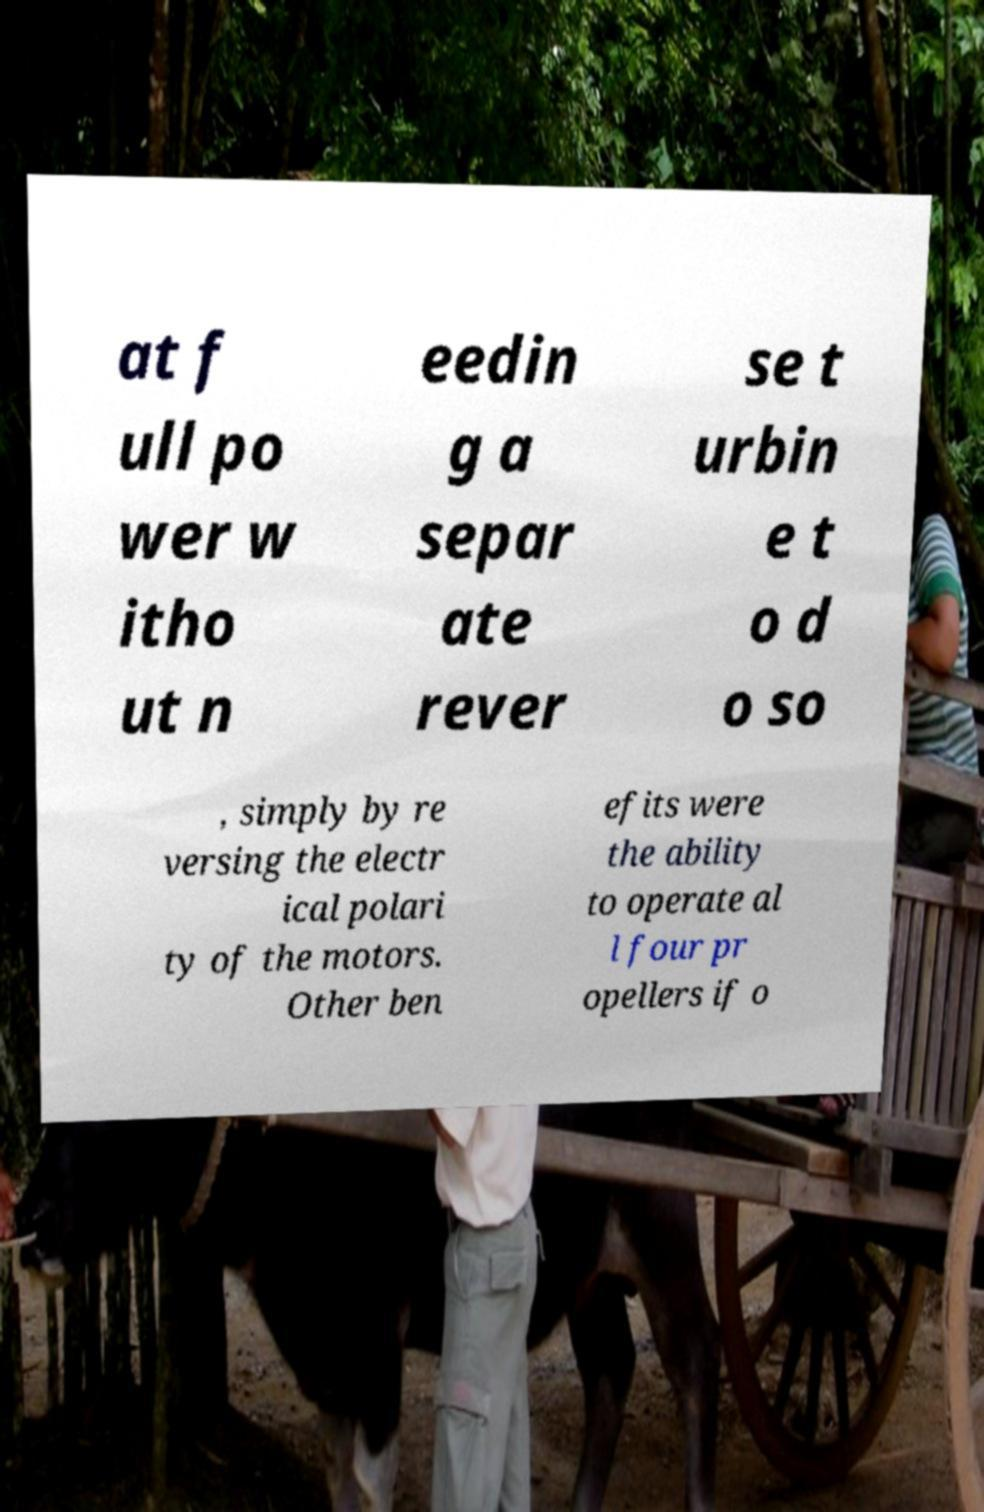Could you assist in decoding the text presented in this image and type it out clearly? at f ull po wer w itho ut n eedin g a separ ate rever se t urbin e t o d o so , simply by re versing the electr ical polari ty of the motors. Other ben efits were the ability to operate al l four pr opellers if o 